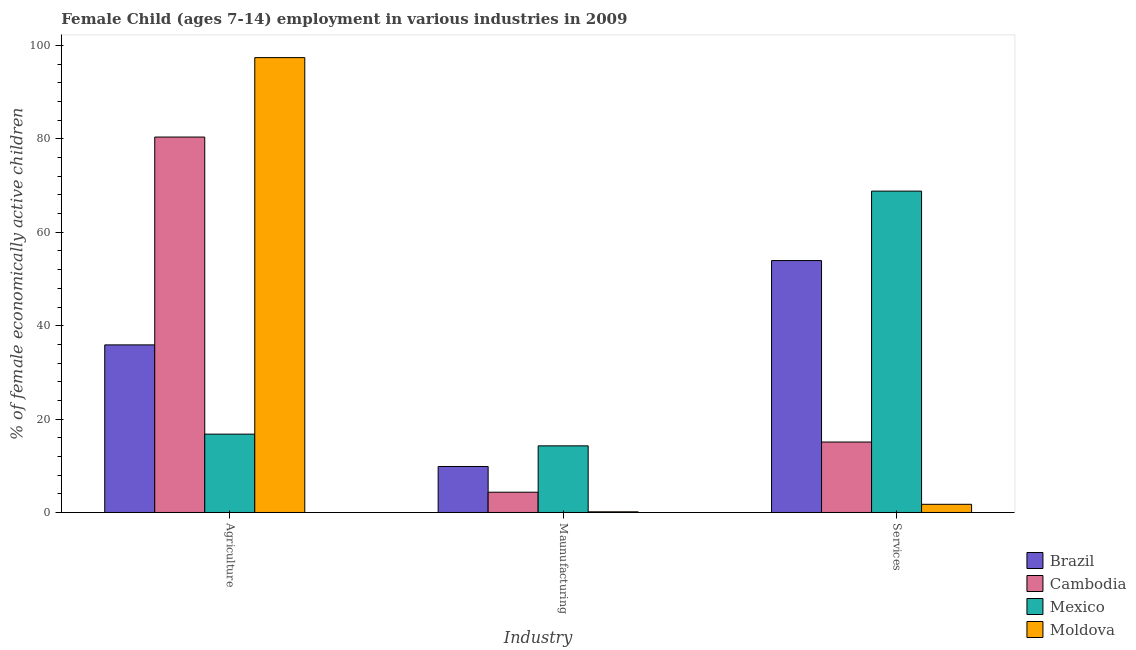How many different coloured bars are there?
Your answer should be very brief. 4. How many bars are there on the 3rd tick from the left?
Give a very brief answer. 4. What is the label of the 1st group of bars from the left?
Ensure brevity in your answer.  Agriculture. What is the percentage of economically active children in manufacturing in Cambodia?
Give a very brief answer. 4.34. Across all countries, what is the maximum percentage of economically active children in services?
Your answer should be compact. 68.82. In which country was the percentage of economically active children in services maximum?
Provide a short and direct response. Mexico. What is the total percentage of economically active children in agriculture in the graph?
Offer a very short reply. 230.48. What is the difference between the percentage of economically active children in services in Cambodia and that in Mexico?
Your response must be concise. -53.73. What is the difference between the percentage of economically active children in manufacturing in Moldova and the percentage of economically active children in services in Cambodia?
Provide a short and direct response. -14.95. What is the average percentage of economically active children in services per country?
Your answer should be very brief. 34.9. What is the difference between the percentage of economically active children in services and percentage of economically active children in manufacturing in Cambodia?
Ensure brevity in your answer.  10.75. In how many countries, is the percentage of economically active children in manufacturing greater than 96 %?
Keep it short and to the point. 0. What is the ratio of the percentage of economically active children in agriculture in Mexico to that in Brazil?
Provide a short and direct response. 0.47. Is the percentage of economically active children in manufacturing in Moldova less than that in Mexico?
Provide a short and direct response. Yes. Is the difference between the percentage of economically active children in manufacturing in Brazil and Cambodia greater than the difference between the percentage of economically active children in services in Brazil and Cambodia?
Offer a terse response. No. What is the difference between the highest and the second highest percentage of economically active children in services?
Your response must be concise. 14.87. What is the difference between the highest and the lowest percentage of economically active children in manufacturing?
Offer a very short reply. 14.13. What does the 1st bar from the right in Maunufacturing represents?
Your answer should be very brief. Moldova. How many countries are there in the graph?
Your response must be concise. 4. What is the difference between two consecutive major ticks on the Y-axis?
Make the answer very short. 20. Does the graph contain any zero values?
Provide a short and direct response. No. Where does the legend appear in the graph?
Ensure brevity in your answer.  Bottom right. What is the title of the graph?
Ensure brevity in your answer.  Female Child (ages 7-14) employment in various industries in 2009. Does "Peru" appear as one of the legend labels in the graph?
Offer a terse response. No. What is the label or title of the X-axis?
Your answer should be compact. Industry. What is the label or title of the Y-axis?
Your response must be concise. % of female economically active children. What is the % of female economically active children of Brazil in Agriculture?
Provide a succinct answer. 35.89. What is the % of female economically active children of Cambodia in Agriculture?
Provide a succinct answer. 80.4. What is the % of female economically active children in Mexico in Agriculture?
Give a very brief answer. 16.78. What is the % of female economically active children of Moldova in Agriculture?
Your response must be concise. 97.41. What is the % of female economically active children in Brazil in Maunufacturing?
Offer a terse response. 9.85. What is the % of female economically active children of Cambodia in Maunufacturing?
Make the answer very short. 4.34. What is the % of female economically active children of Mexico in Maunufacturing?
Keep it short and to the point. 14.27. What is the % of female economically active children of Moldova in Maunufacturing?
Ensure brevity in your answer.  0.14. What is the % of female economically active children of Brazil in Services?
Make the answer very short. 53.95. What is the % of female economically active children in Cambodia in Services?
Offer a very short reply. 15.09. What is the % of female economically active children in Mexico in Services?
Offer a very short reply. 68.82. What is the % of female economically active children of Moldova in Services?
Give a very brief answer. 1.75. Across all Industry, what is the maximum % of female economically active children in Brazil?
Your response must be concise. 53.95. Across all Industry, what is the maximum % of female economically active children in Cambodia?
Give a very brief answer. 80.4. Across all Industry, what is the maximum % of female economically active children in Mexico?
Your answer should be compact. 68.82. Across all Industry, what is the maximum % of female economically active children of Moldova?
Give a very brief answer. 97.41. Across all Industry, what is the minimum % of female economically active children of Brazil?
Make the answer very short. 9.85. Across all Industry, what is the minimum % of female economically active children in Cambodia?
Provide a short and direct response. 4.34. Across all Industry, what is the minimum % of female economically active children of Mexico?
Your answer should be very brief. 14.27. Across all Industry, what is the minimum % of female economically active children in Moldova?
Keep it short and to the point. 0.14. What is the total % of female economically active children in Brazil in the graph?
Keep it short and to the point. 99.69. What is the total % of female economically active children of Cambodia in the graph?
Your answer should be compact. 99.83. What is the total % of female economically active children of Mexico in the graph?
Give a very brief answer. 99.87. What is the total % of female economically active children of Moldova in the graph?
Ensure brevity in your answer.  99.3. What is the difference between the % of female economically active children in Brazil in Agriculture and that in Maunufacturing?
Provide a succinct answer. 26.04. What is the difference between the % of female economically active children of Cambodia in Agriculture and that in Maunufacturing?
Your response must be concise. 76.06. What is the difference between the % of female economically active children of Mexico in Agriculture and that in Maunufacturing?
Make the answer very short. 2.51. What is the difference between the % of female economically active children of Moldova in Agriculture and that in Maunufacturing?
Make the answer very short. 97.27. What is the difference between the % of female economically active children of Brazil in Agriculture and that in Services?
Your response must be concise. -18.06. What is the difference between the % of female economically active children of Cambodia in Agriculture and that in Services?
Your answer should be compact. 65.31. What is the difference between the % of female economically active children of Mexico in Agriculture and that in Services?
Provide a succinct answer. -52.04. What is the difference between the % of female economically active children in Moldova in Agriculture and that in Services?
Your answer should be very brief. 95.66. What is the difference between the % of female economically active children of Brazil in Maunufacturing and that in Services?
Ensure brevity in your answer.  -44.1. What is the difference between the % of female economically active children of Cambodia in Maunufacturing and that in Services?
Your answer should be very brief. -10.75. What is the difference between the % of female economically active children in Mexico in Maunufacturing and that in Services?
Make the answer very short. -54.55. What is the difference between the % of female economically active children in Moldova in Maunufacturing and that in Services?
Offer a terse response. -1.61. What is the difference between the % of female economically active children of Brazil in Agriculture and the % of female economically active children of Cambodia in Maunufacturing?
Offer a very short reply. 31.55. What is the difference between the % of female economically active children in Brazil in Agriculture and the % of female economically active children in Mexico in Maunufacturing?
Your answer should be very brief. 21.62. What is the difference between the % of female economically active children of Brazil in Agriculture and the % of female economically active children of Moldova in Maunufacturing?
Your answer should be compact. 35.75. What is the difference between the % of female economically active children in Cambodia in Agriculture and the % of female economically active children in Mexico in Maunufacturing?
Your response must be concise. 66.13. What is the difference between the % of female economically active children of Cambodia in Agriculture and the % of female economically active children of Moldova in Maunufacturing?
Offer a terse response. 80.26. What is the difference between the % of female economically active children of Mexico in Agriculture and the % of female economically active children of Moldova in Maunufacturing?
Your response must be concise. 16.64. What is the difference between the % of female economically active children of Brazil in Agriculture and the % of female economically active children of Cambodia in Services?
Ensure brevity in your answer.  20.8. What is the difference between the % of female economically active children of Brazil in Agriculture and the % of female economically active children of Mexico in Services?
Your response must be concise. -32.93. What is the difference between the % of female economically active children in Brazil in Agriculture and the % of female economically active children in Moldova in Services?
Give a very brief answer. 34.14. What is the difference between the % of female economically active children of Cambodia in Agriculture and the % of female economically active children of Mexico in Services?
Make the answer very short. 11.58. What is the difference between the % of female economically active children of Cambodia in Agriculture and the % of female economically active children of Moldova in Services?
Your answer should be compact. 78.65. What is the difference between the % of female economically active children of Mexico in Agriculture and the % of female economically active children of Moldova in Services?
Provide a short and direct response. 15.03. What is the difference between the % of female economically active children in Brazil in Maunufacturing and the % of female economically active children in Cambodia in Services?
Make the answer very short. -5.24. What is the difference between the % of female economically active children in Brazil in Maunufacturing and the % of female economically active children in Mexico in Services?
Provide a short and direct response. -58.97. What is the difference between the % of female economically active children of Cambodia in Maunufacturing and the % of female economically active children of Mexico in Services?
Ensure brevity in your answer.  -64.48. What is the difference between the % of female economically active children of Cambodia in Maunufacturing and the % of female economically active children of Moldova in Services?
Provide a succinct answer. 2.59. What is the difference between the % of female economically active children of Mexico in Maunufacturing and the % of female economically active children of Moldova in Services?
Your response must be concise. 12.52. What is the average % of female economically active children in Brazil per Industry?
Provide a succinct answer. 33.23. What is the average % of female economically active children in Cambodia per Industry?
Provide a short and direct response. 33.28. What is the average % of female economically active children in Mexico per Industry?
Give a very brief answer. 33.29. What is the average % of female economically active children of Moldova per Industry?
Offer a terse response. 33.1. What is the difference between the % of female economically active children in Brazil and % of female economically active children in Cambodia in Agriculture?
Provide a short and direct response. -44.51. What is the difference between the % of female economically active children of Brazil and % of female economically active children of Mexico in Agriculture?
Ensure brevity in your answer.  19.11. What is the difference between the % of female economically active children of Brazil and % of female economically active children of Moldova in Agriculture?
Your answer should be compact. -61.52. What is the difference between the % of female economically active children of Cambodia and % of female economically active children of Mexico in Agriculture?
Provide a short and direct response. 63.62. What is the difference between the % of female economically active children of Cambodia and % of female economically active children of Moldova in Agriculture?
Provide a succinct answer. -17.01. What is the difference between the % of female economically active children of Mexico and % of female economically active children of Moldova in Agriculture?
Offer a very short reply. -80.63. What is the difference between the % of female economically active children in Brazil and % of female economically active children in Cambodia in Maunufacturing?
Your answer should be compact. 5.51. What is the difference between the % of female economically active children in Brazil and % of female economically active children in Mexico in Maunufacturing?
Provide a succinct answer. -4.42. What is the difference between the % of female economically active children in Brazil and % of female economically active children in Moldova in Maunufacturing?
Provide a succinct answer. 9.71. What is the difference between the % of female economically active children in Cambodia and % of female economically active children in Mexico in Maunufacturing?
Make the answer very short. -9.93. What is the difference between the % of female economically active children of Cambodia and % of female economically active children of Moldova in Maunufacturing?
Provide a succinct answer. 4.2. What is the difference between the % of female economically active children of Mexico and % of female economically active children of Moldova in Maunufacturing?
Provide a succinct answer. 14.13. What is the difference between the % of female economically active children in Brazil and % of female economically active children in Cambodia in Services?
Your answer should be very brief. 38.86. What is the difference between the % of female economically active children of Brazil and % of female economically active children of Mexico in Services?
Your answer should be very brief. -14.87. What is the difference between the % of female economically active children of Brazil and % of female economically active children of Moldova in Services?
Provide a succinct answer. 52.2. What is the difference between the % of female economically active children in Cambodia and % of female economically active children in Mexico in Services?
Offer a very short reply. -53.73. What is the difference between the % of female economically active children in Cambodia and % of female economically active children in Moldova in Services?
Your answer should be very brief. 13.34. What is the difference between the % of female economically active children of Mexico and % of female economically active children of Moldova in Services?
Your answer should be very brief. 67.07. What is the ratio of the % of female economically active children of Brazil in Agriculture to that in Maunufacturing?
Ensure brevity in your answer.  3.64. What is the ratio of the % of female economically active children of Cambodia in Agriculture to that in Maunufacturing?
Provide a succinct answer. 18.53. What is the ratio of the % of female economically active children of Mexico in Agriculture to that in Maunufacturing?
Keep it short and to the point. 1.18. What is the ratio of the % of female economically active children in Moldova in Agriculture to that in Maunufacturing?
Provide a succinct answer. 695.79. What is the ratio of the % of female economically active children in Brazil in Agriculture to that in Services?
Provide a succinct answer. 0.67. What is the ratio of the % of female economically active children in Cambodia in Agriculture to that in Services?
Your response must be concise. 5.33. What is the ratio of the % of female economically active children of Mexico in Agriculture to that in Services?
Keep it short and to the point. 0.24. What is the ratio of the % of female economically active children of Moldova in Agriculture to that in Services?
Provide a succinct answer. 55.66. What is the ratio of the % of female economically active children of Brazil in Maunufacturing to that in Services?
Keep it short and to the point. 0.18. What is the ratio of the % of female economically active children of Cambodia in Maunufacturing to that in Services?
Your answer should be very brief. 0.29. What is the ratio of the % of female economically active children in Mexico in Maunufacturing to that in Services?
Your response must be concise. 0.21. What is the difference between the highest and the second highest % of female economically active children of Brazil?
Your answer should be very brief. 18.06. What is the difference between the highest and the second highest % of female economically active children in Cambodia?
Give a very brief answer. 65.31. What is the difference between the highest and the second highest % of female economically active children in Mexico?
Your answer should be very brief. 52.04. What is the difference between the highest and the second highest % of female economically active children in Moldova?
Provide a short and direct response. 95.66. What is the difference between the highest and the lowest % of female economically active children in Brazil?
Give a very brief answer. 44.1. What is the difference between the highest and the lowest % of female economically active children in Cambodia?
Provide a succinct answer. 76.06. What is the difference between the highest and the lowest % of female economically active children of Mexico?
Keep it short and to the point. 54.55. What is the difference between the highest and the lowest % of female economically active children of Moldova?
Keep it short and to the point. 97.27. 